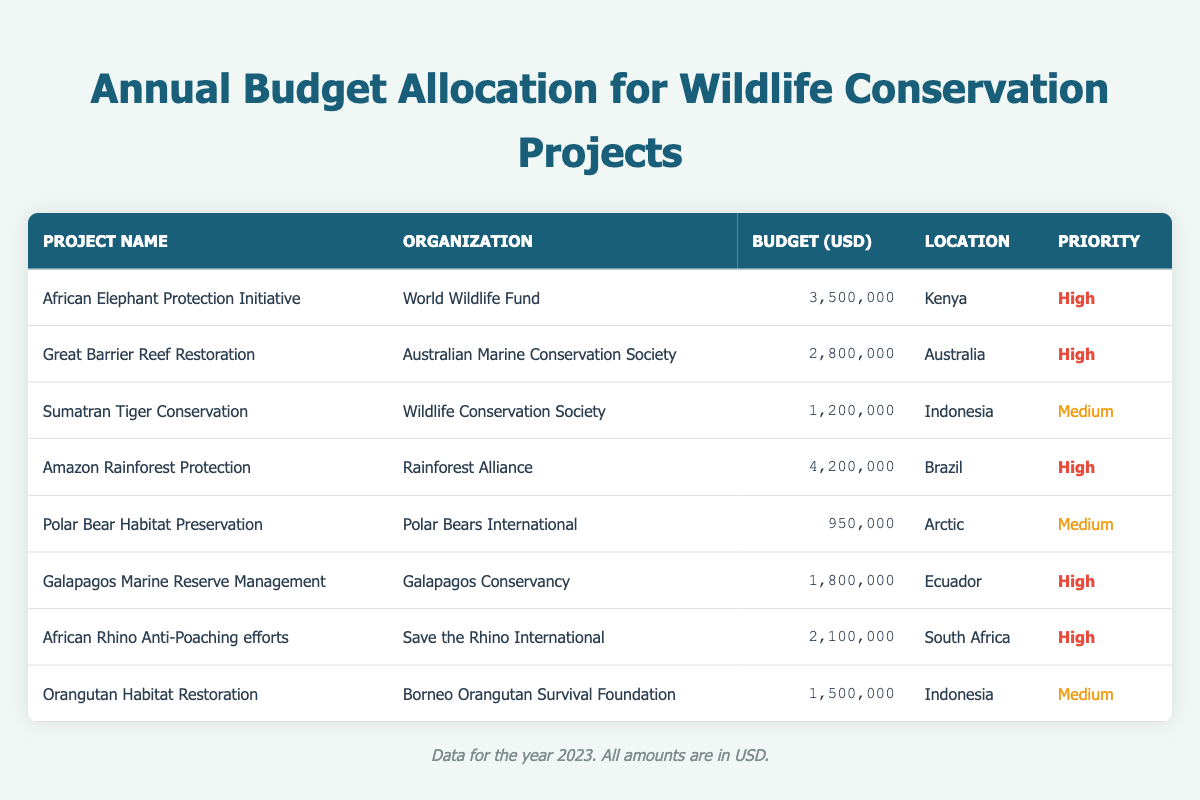What is the total budget allocated for the African Elephant Protection Initiative? The budget for the African Elephant Protection Initiative can be found in the table, listed as 3,500,000 USD.
Answer: 3,500,000 Which organization is responsible for the Sumatran Tiger Conservation project? The organization managing the Sumatran Tiger Conservation project is the Wildlife Conservation Society, as indicated in the table under the relevant project.
Answer: Wildlife Conservation Society How many conservation projects have a "High" priority? By counting the rows labeled as "High" in the priority column, we find that there are five such projects listed in the table.
Answer: 5 What is the budget difference between the Amazon Rainforest Protection and Polar Bear Habitat Preservation projects? The budget for the Amazon Rainforest Protection project is 4,200,000 USD, while the budget for the Polar Bear Habitat Preservation project is 950,000 USD. The difference is calculated as 4,200,000 - 950,000 = 3,250,000 USD.
Answer: 3,250,000 Is the Galapagos Marine Reserve Management project budget higher than the African Rhino Anti-Poaching efforts budget? The budget for the Galapagos Marine Reserve Management project is 1,800,000 USD, and for the African Rhino Anti-Poaching efforts, it is 2,100,000 USD. Since 1,800,000 is less than 2,100,000, the answer is no.
Answer: No What is the average budget of all projects listed in the table? To find the average, first, sum up the budgets: 3,500,000 + 2,800,000 + 1,200,000 + 4,200,000 + 950,000 + 1,800,000 + 2,100,000 + 1,500,000 = 18,050,000 USD. There are 8 projects, so the average is 18,050,000 / 8 = 2,256,250 USD.
Answer: 2,256,250 Which project has the highest budget allocation, and what is that amount? Scanning the budget column, the highest budget allocation is for the Amazon Rainforest Protection project, with a total of 4,200,000 USD.
Answer: Amazon Rainforest Protection, 4,200,000 Are there any conservation projects located in Indonesia? The table shows two projects associated with Indonesia: Sumatran Tiger Conservation and Orangutan Habitat Restoration, confirming the existence of projects in that country.
Answer: Yes 